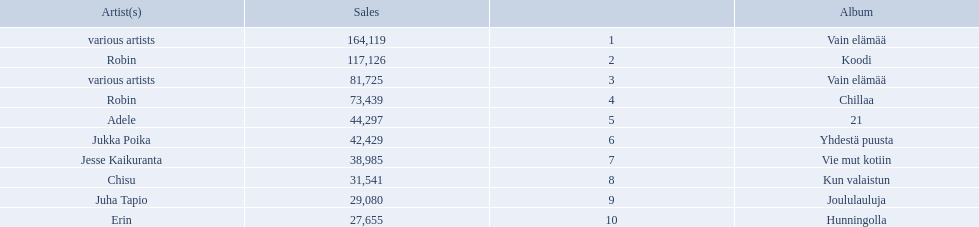What sales does adele have? 44,297. What sales does chisu have? 31,541. Which of these numbers are higher? 44,297. Who has this number of sales? Adele. 